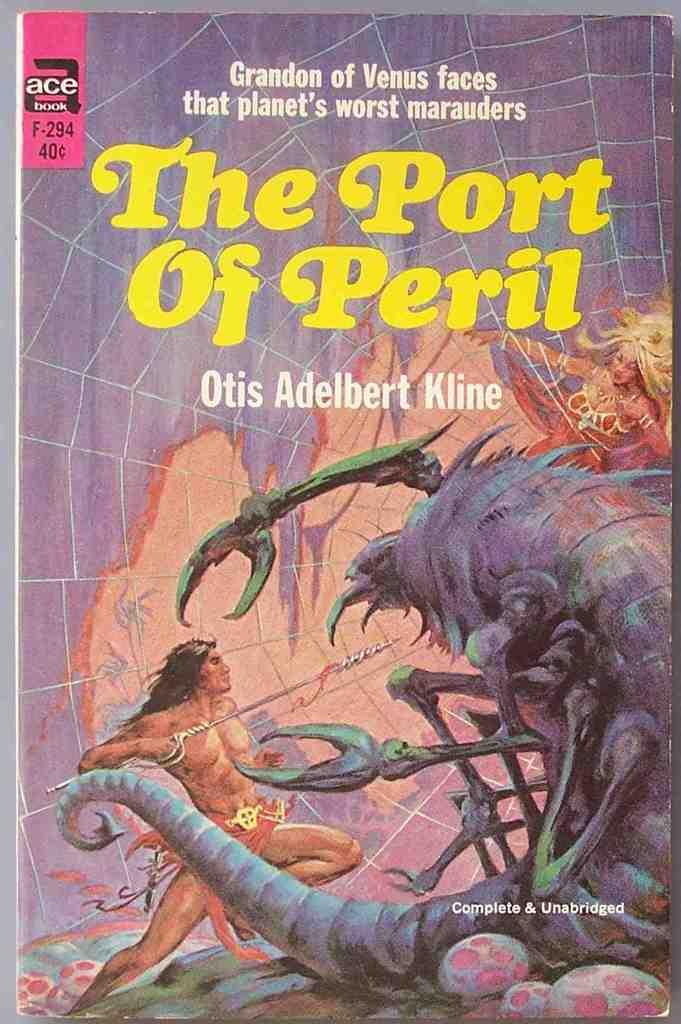<image>
Describe the image concisely. The Port of Peril is a novel that has cover art displaying violence. 